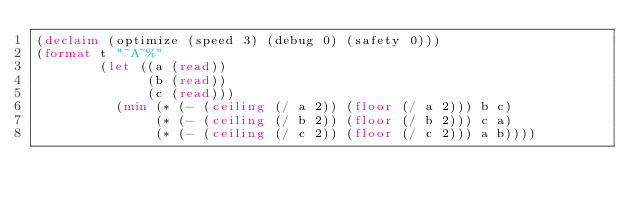Convert code to text. <code><loc_0><loc_0><loc_500><loc_500><_Lisp_>(declaim (optimize (speed 3) (debug 0) (safety 0)))
(format t "~A~%"
        (let ((a (read))
              (b (read))
              (c (read)))
          (min (* (- (ceiling (/ a 2)) (floor (/ a 2))) b c)
               (* (- (ceiling (/ b 2)) (floor (/ b 2))) c a)
               (* (- (ceiling (/ c 2)) (floor (/ c 2))) a b))))</code> 